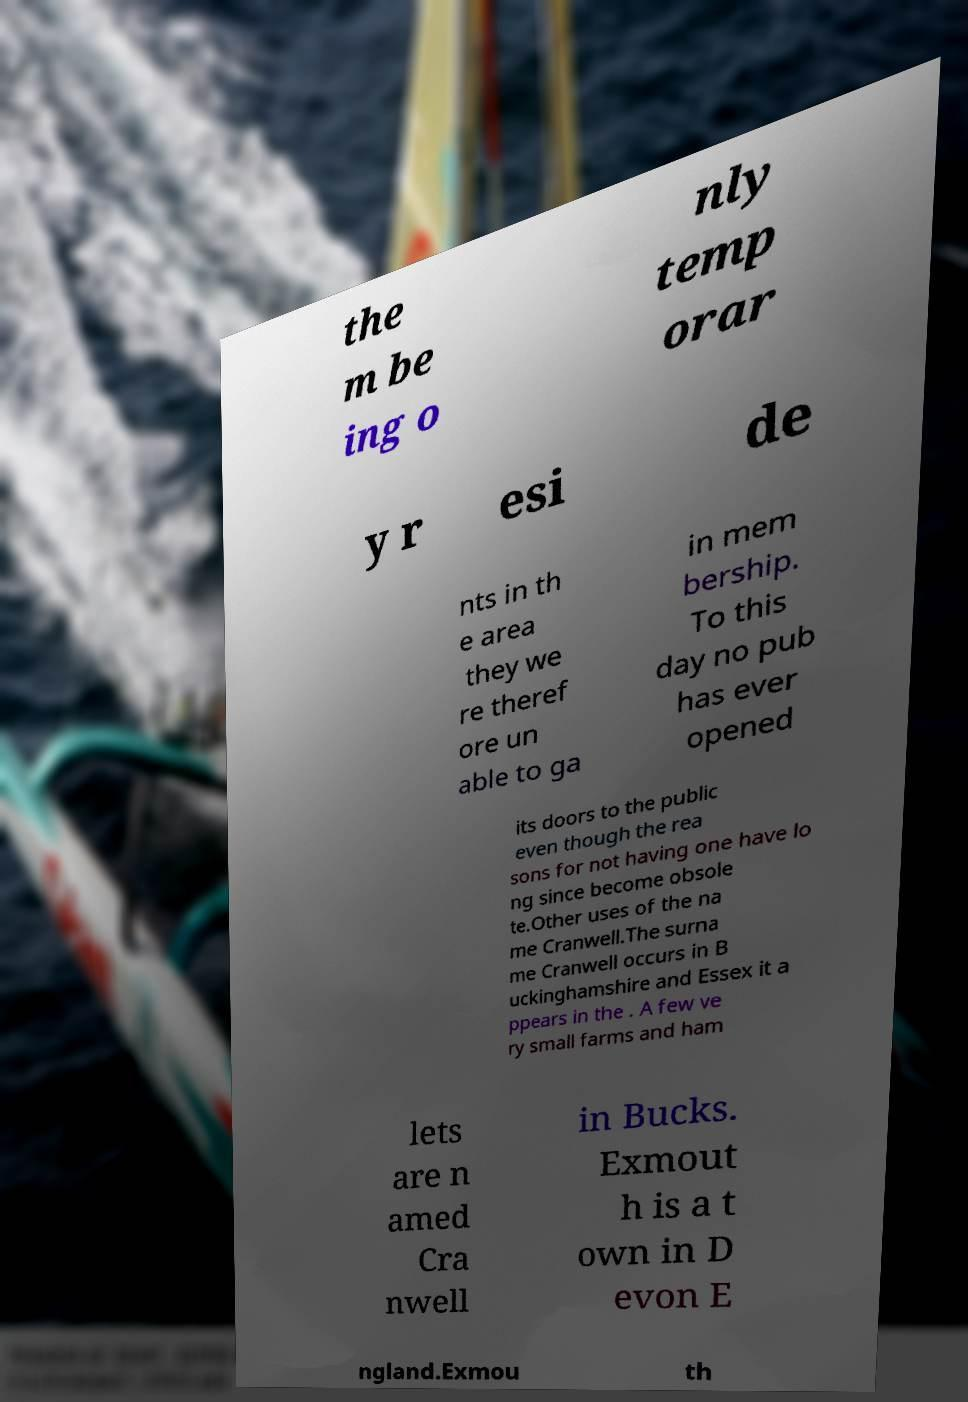Please identify and transcribe the text found in this image. the m be ing o nly temp orar y r esi de nts in th e area they we re theref ore un able to ga in mem bership. To this day no pub has ever opened its doors to the public even though the rea sons for not having one have lo ng since become obsole te.Other uses of the na me Cranwell.The surna me Cranwell occurs in B uckinghamshire and Essex it a ppears in the . A few ve ry small farms and ham lets are n amed Cra nwell in Bucks. Exmout h is a t own in D evon E ngland.Exmou th 